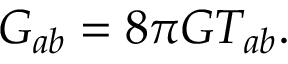<formula> <loc_0><loc_0><loc_500><loc_500>G _ { a b } = 8 \pi G T _ { a b } .</formula> 